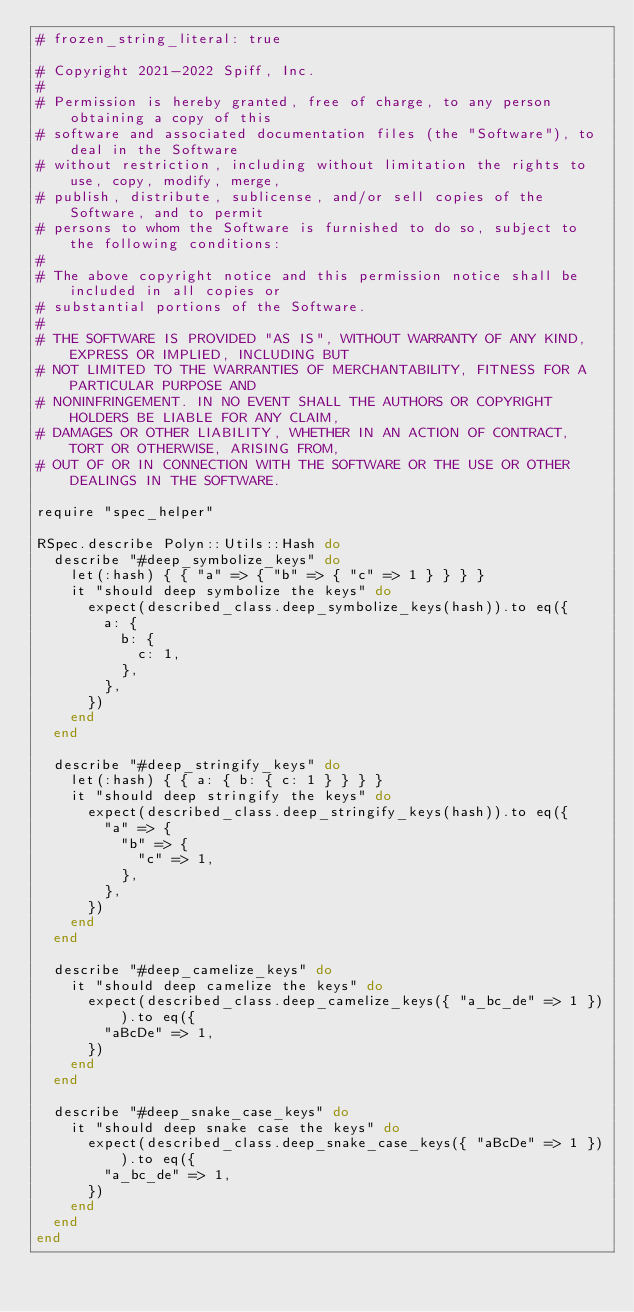Convert code to text. <code><loc_0><loc_0><loc_500><loc_500><_Ruby_># frozen_string_literal: true

# Copyright 2021-2022 Spiff, Inc.
#
# Permission is hereby granted, free of charge, to any person obtaining a copy of this
# software and associated documentation files (the "Software"), to deal in the Software
# without restriction, including without limitation the rights to use, copy, modify, merge,
# publish, distribute, sublicense, and/or sell copies of the Software, and to permit
# persons to whom the Software is furnished to do so, subject to the following conditions:
#
# The above copyright notice and this permission notice shall be included in all copies or
# substantial portions of the Software.
#
# THE SOFTWARE IS PROVIDED "AS IS", WITHOUT WARRANTY OF ANY KIND, EXPRESS OR IMPLIED, INCLUDING BUT
# NOT LIMITED TO THE WARRANTIES OF MERCHANTABILITY, FITNESS FOR A PARTICULAR PURPOSE AND
# NONINFRINGEMENT. IN NO EVENT SHALL THE AUTHORS OR COPYRIGHT HOLDERS BE LIABLE FOR ANY CLAIM,
# DAMAGES OR OTHER LIABILITY, WHETHER IN AN ACTION OF CONTRACT, TORT OR OTHERWISE, ARISING FROM,
# OUT OF OR IN CONNECTION WITH THE SOFTWARE OR THE USE OR OTHER DEALINGS IN THE SOFTWARE.

require "spec_helper"

RSpec.describe Polyn::Utils::Hash do
  describe "#deep_symbolize_keys" do
    let(:hash) { { "a" => { "b" => { "c" => 1 } } } }
    it "should deep symbolize the keys" do
      expect(described_class.deep_symbolize_keys(hash)).to eq({
        a: {
          b: {
            c: 1,
          },
        },
      })
    end
  end

  describe "#deep_stringify_keys" do
    let(:hash) { { a: { b: { c: 1 } } } }
    it "should deep stringify the keys" do
      expect(described_class.deep_stringify_keys(hash)).to eq({
        "a" => {
          "b" => {
            "c" => 1,
          },
        },
      })
    end
  end

  describe "#deep_camelize_keys" do
    it "should deep camelize the keys" do
      expect(described_class.deep_camelize_keys({ "a_bc_de" => 1 })).to eq({
        "aBcDe" => 1,
      })
    end
  end

  describe "#deep_snake_case_keys" do
    it "should deep snake case the keys" do
      expect(described_class.deep_snake_case_keys({ "aBcDe" => 1 })).to eq({
        "a_bc_de" => 1,
      })
    end
  end
end
</code> 